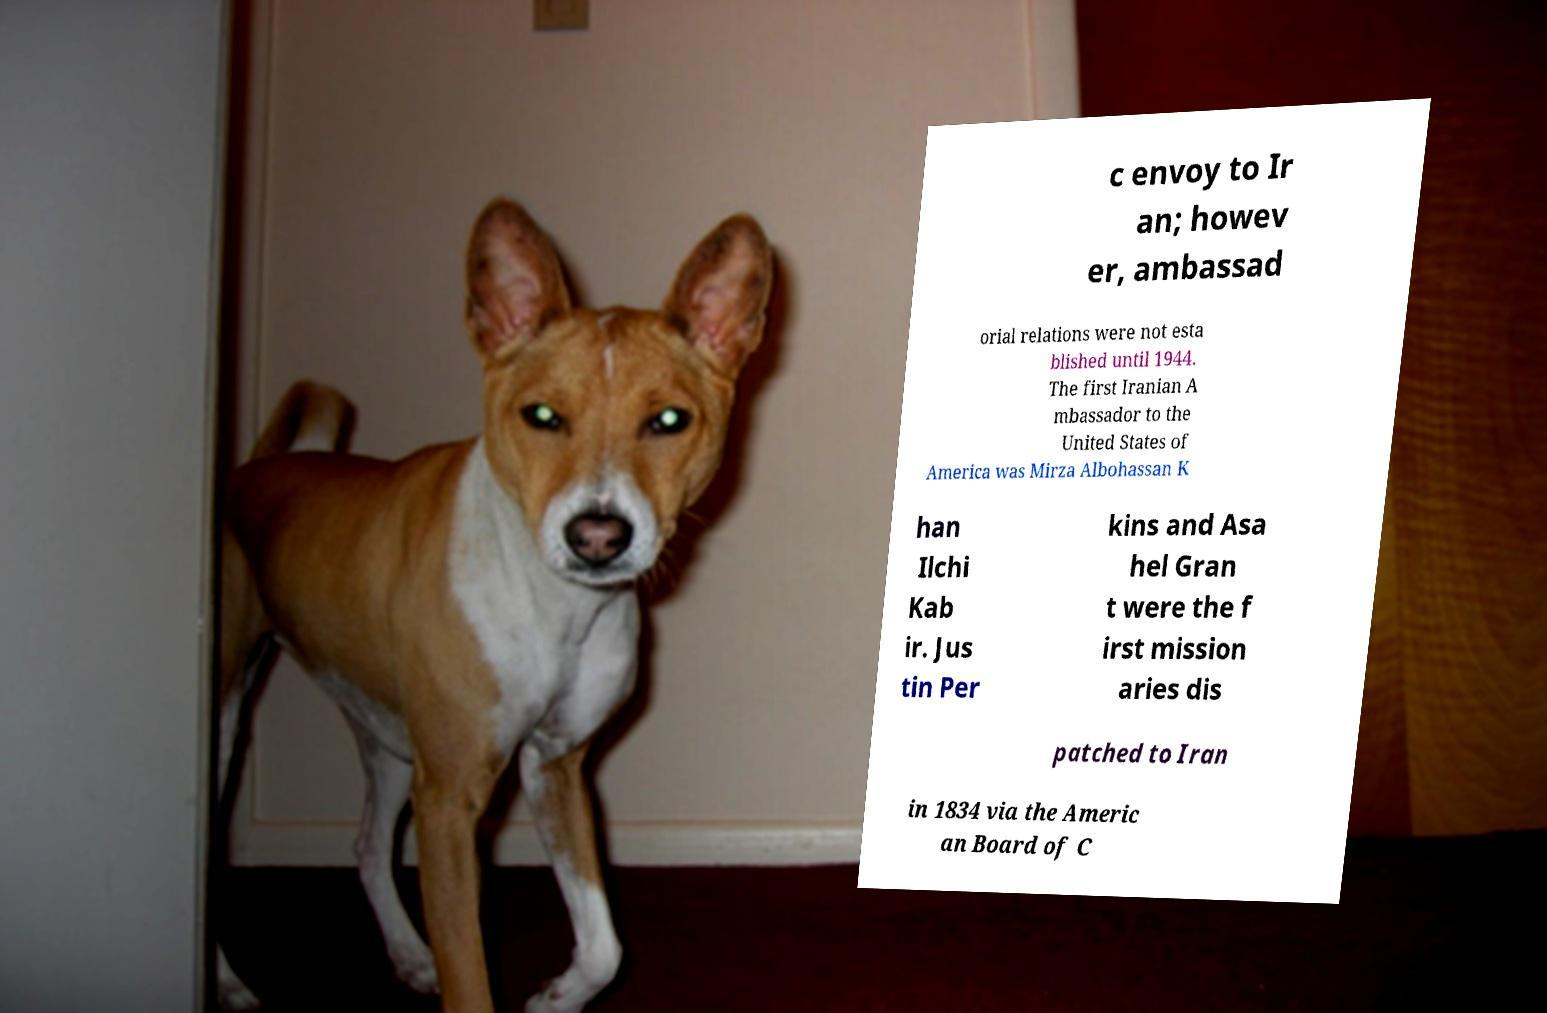I need the written content from this picture converted into text. Can you do that? c envoy to Ir an; howev er, ambassad orial relations were not esta blished until 1944. The first Iranian A mbassador to the United States of America was Mirza Albohassan K han Ilchi Kab ir. Jus tin Per kins and Asa hel Gran t were the f irst mission aries dis patched to Iran in 1834 via the Americ an Board of C 